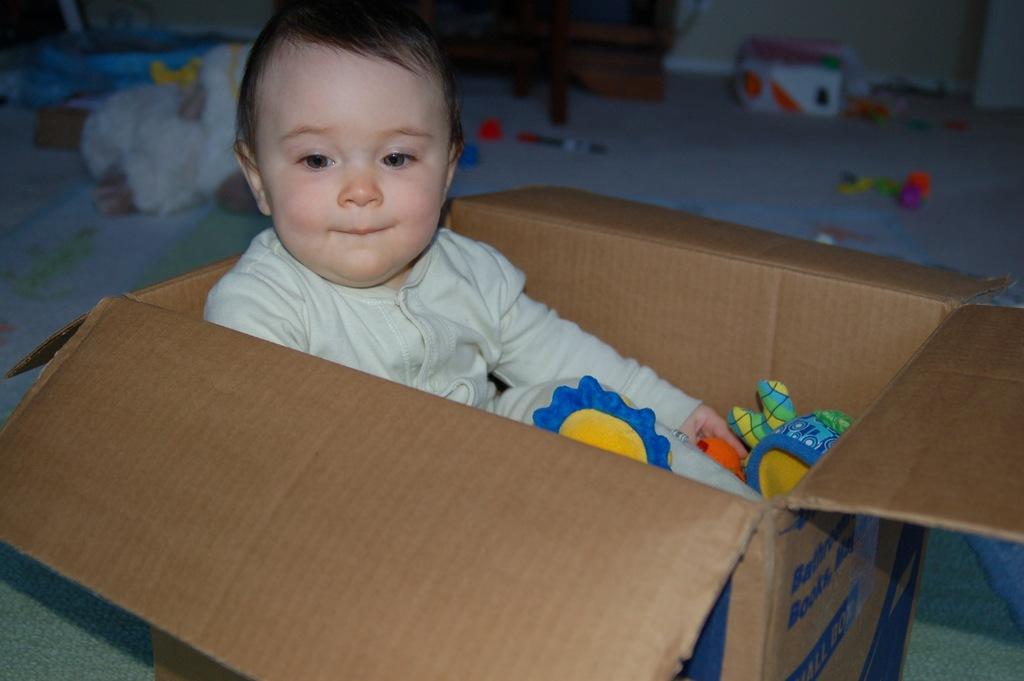In one or two sentences, can you explain what this image depicts? In the image we can see a baby wearing clothes and the baby is sitting in the carton box. We can even see there are toys in the carton box. Here we can see the floor and the background is slightly blurred. 